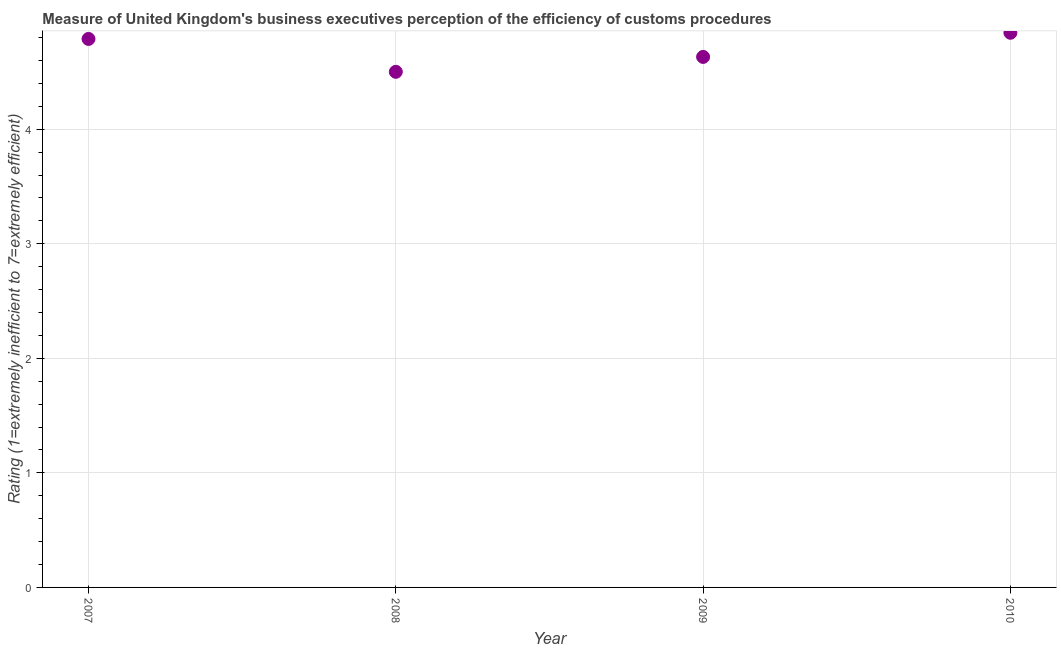What is the rating measuring burden of customs procedure in 2009?
Keep it short and to the point. 4.63. Across all years, what is the maximum rating measuring burden of customs procedure?
Give a very brief answer. 4.84. Across all years, what is the minimum rating measuring burden of customs procedure?
Make the answer very short. 4.5. In which year was the rating measuring burden of customs procedure maximum?
Give a very brief answer. 2010. What is the sum of the rating measuring burden of customs procedure?
Ensure brevity in your answer.  18.76. What is the difference between the rating measuring burden of customs procedure in 2007 and 2008?
Your response must be concise. 0.29. What is the average rating measuring burden of customs procedure per year?
Your response must be concise. 4.69. What is the median rating measuring burden of customs procedure?
Offer a terse response. 4.71. In how many years, is the rating measuring burden of customs procedure greater than 4.2 ?
Provide a succinct answer. 4. Do a majority of the years between 2007 and 2008 (inclusive) have rating measuring burden of customs procedure greater than 3.6 ?
Provide a short and direct response. Yes. What is the ratio of the rating measuring burden of customs procedure in 2009 to that in 2010?
Provide a short and direct response. 0.96. What is the difference between the highest and the second highest rating measuring burden of customs procedure?
Make the answer very short. 0.05. What is the difference between the highest and the lowest rating measuring burden of customs procedure?
Provide a short and direct response. 0.34. How many years are there in the graph?
Your response must be concise. 4. Are the values on the major ticks of Y-axis written in scientific E-notation?
Keep it short and to the point. No. Does the graph contain grids?
Provide a succinct answer. Yes. What is the title of the graph?
Make the answer very short. Measure of United Kingdom's business executives perception of the efficiency of customs procedures. What is the label or title of the X-axis?
Offer a very short reply. Year. What is the label or title of the Y-axis?
Ensure brevity in your answer.  Rating (1=extremely inefficient to 7=extremely efficient). What is the Rating (1=extremely inefficient to 7=extremely efficient) in 2007?
Provide a succinct answer. 4.79. What is the Rating (1=extremely inefficient to 7=extremely efficient) in 2008?
Your response must be concise. 4.5. What is the Rating (1=extremely inefficient to 7=extremely efficient) in 2009?
Offer a terse response. 4.63. What is the Rating (1=extremely inefficient to 7=extremely efficient) in 2010?
Keep it short and to the point. 4.84. What is the difference between the Rating (1=extremely inefficient to 7=extremely efficient) in 2007 and 2008?
Your answer should be compact. 0.29. What is the difference between the Rating (1=extremely inefficient to 7=extremely efficient) in 2007 and 2009?
Give a very brief answer. 0.16. What is the difference between the Rating (1=extremely inefficient to 7=extremely efficient) in 2007 and 2010?
Your answer should be very brief. -0.05. What is the difference between the Rating (1=extremely inefficient to 7=extremely efficient) in 2008 and 2009?
Provide a short and direct response. -0.13. What is the difference between the Rating (1=extremely inefficient to 7=extremely efficient) in 2008 and 2010?
Make the answer very short. -0.34. What is the difference between the Rating (1=extremely inefficient to 7=extremely efficient) in 2009 and 2010?
Give a very brief answer. -0.21. What is the ratio of the Rating (1=extremely inefficient to 7=extremely efficient) in 2007 to that in 2008?
Your response must be concise. 1.06. What is the ratio of the Rating (1=extremely inefficient to 7=extremely efficient) in 2007 to that in 2009?
Provide a short and direct response. 1.03. What is the ratio of the Rating (1=extremely inefficient to 7=extremely efficient) in 2007 to that in 2010?
Keep it short and to the point. 0.99. What is the ratio of the Rating (1=extremely inefficient to 7=extremely efficient) in 2008 to that in 2010?
Give a very brief answer. 0.93. What is the ratio of the Rating (1=extremely inefficient to 7=extremely efficient) in 2009 to that in 2010?
Keep it short and to the point. 0.96. 